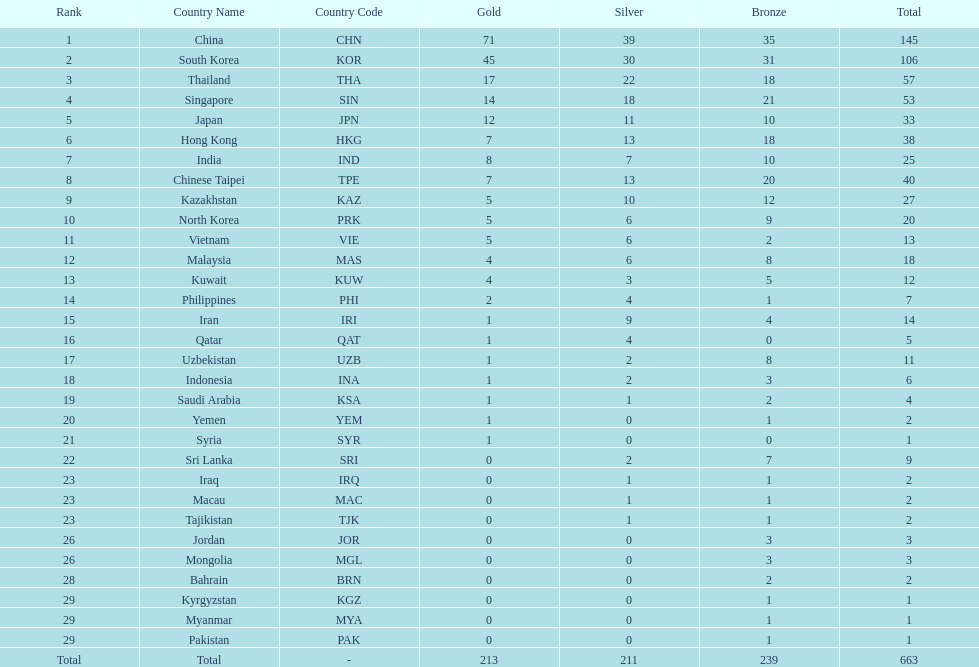Could you help me parse every detail presented in this table? {'header': ['Rank', 'Country Name', 'Country Code', 'Gold', 'Silver', 'Bronze', 'Total'], 'rows': [['1', 'China', 'CHN', '71', '39', '35', '145'], ['2', 'South Korea', 'KOR', '45', '30', '31', '106'], ['3', 'Thailand', 'THA', '17', '22', '18', '57'], ['4', 'Singapore', 'SIN', '14', '18', '21', '53'], ['5', 'Japan', 'JPN', '12', '11', '10', '33'], ['6', 'Hong Kong', 'HKG', '7', '13', '18', '38'], ['7', 'India', 'IND', '8', '7', '10', '25'], ['8', 'Chinese Taipei', 'TPE', '7', '13', '20', '40'], ['9', 'Kazakhstan', 'KAZ', '5', '10', '12', '27'], ['10', 'North Korea', 'PRK', '5', '6', '9', '20'], ['11', 'Vietnam', 'VIE', '5', '6', '2', '13'], ['12', 'Malaysia', 'MAS', '4', '6', '8', '18'], ['13', 'Kuwait', 'KUW', '4', '3', '5', '12'], ['14', 'Philippines', 'PHI', '2', '4', '1', '7'], ['15', 'Iran', 'IRI', '1', '9', '4', '14'], ['16', 'Qatar', 'QAT', '1', '4', '0', '5'], ['17', 'Uzbekistan', 'UZB', '1', '2', '8', '11'], ['18', 'Indonesia', 'INA', '1', '2', '3', '6'], ['19', 'Saudi Arabia', 'KSA', '1', '1', '2', '4'], ['20', 'Yemen', 'YEM', '1', '0', '1', '2'], ['21', 'Syria', 'SYR', '1', '0', '0', '1'], ['22', 'Sri Lanka', 'SRI', '0', '2', '7', '9'], ['23', 'Iraq', 'IRQ', '0', '1', '1', '2'], ['23', 'Macau', 'MAC', '0', '1', '1', '2'], ['23', 'Tajikistan', 'TJK', '0', '1', '1', '2'], ['26', 'Jordan', 'JOR', '0', '0', '3', '3'], ['26', 'Mongolia', 'MGL', '0', '0', '3', '3'], ['28', 'Bahrain', 'BRN', '0', '0', '2', '2'], ['29', 'Kyrgyzstan', 'KGZ', '0', '0', '1', '1'], ['29', 'Myanmar', 'MYA', '0', '0', '1', '1'], ['29', 'Pakistan', 'PAK', '0', '0', '1', '1'], ['Total', 'Total', '-', '213', '211', '239', '663']]} What is the total number of medals that india won in the asian youth games? 25. 